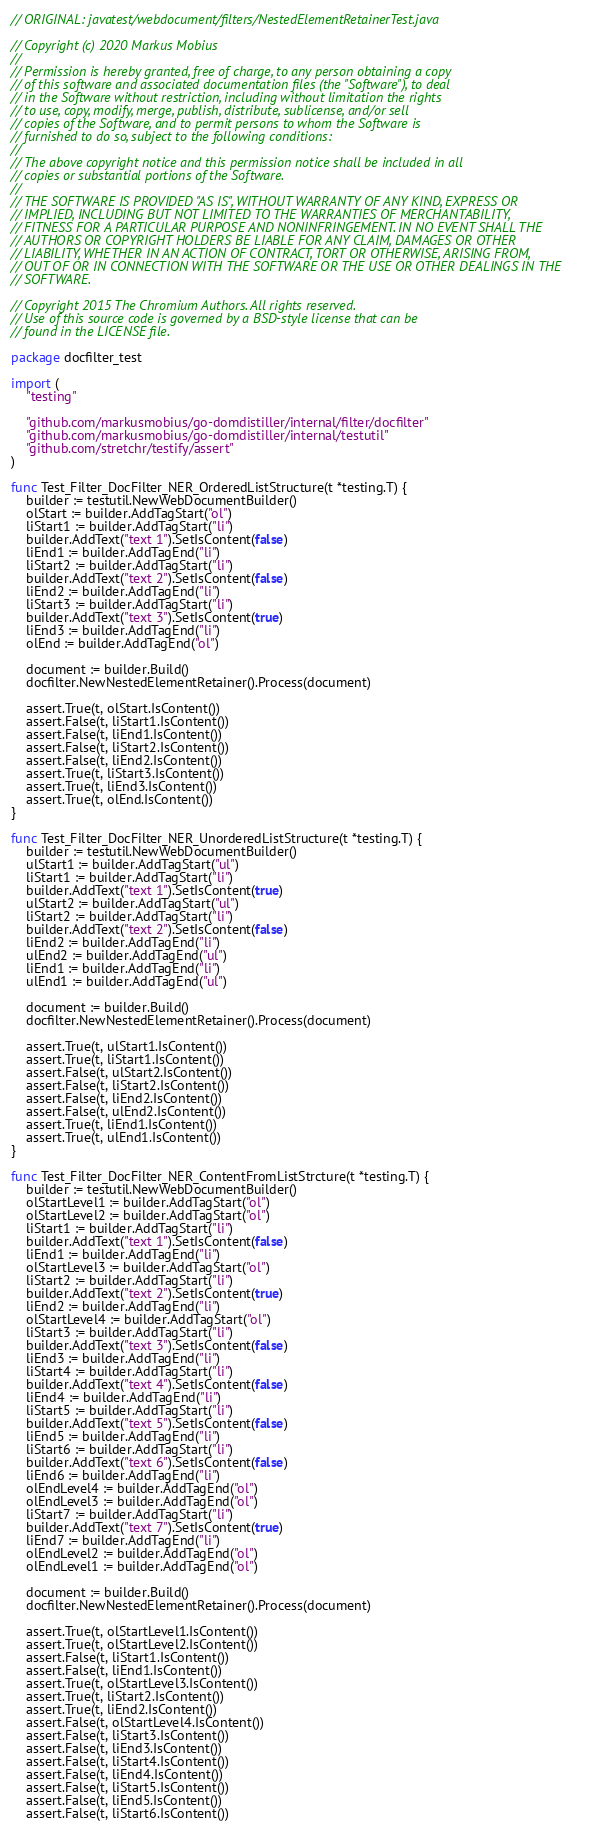Convert code to text. <code><loc_0><loc_0><loc_500><loc_500><_Go_>// ORIGINAL: javatest/webdocument/filters/NestedElementRetainerTest.java

// Copyright (c) 2020 Markus Mobius
//
// Permission is hereby granted, free of charge, to any person obtaining a copy
// of this software and associated documentation files (the "Software"), to deal
// in the Software without restriction, including without limitation the rights
// to use, copy, modify, merge, publish, distribute, sublicense, and/or sell
// copies of the Software, and to permit persons to whom the Software is
// furnished to do so, subject to the following conditions:
//
// The above copyright notice and this permission notice shall be included in all
// copies or substantial portions of the Software.
//
// THE SOFTWARE IS PROVIDED "AS IS", WITHOUT WARRANTY OF ANY KIND, EXPRESS OR
// IMPLIED, INCLUDING BUT NOT LIMITED TO THE WARRANTIES OF MERCHANTABILITY,
// FITNESS FOR A PARTICULAR PURPOSE AND NONINFRINGEMENT. IN NO EVENT SHALL THE
// AUTHORS OR COPYRIGHT HOLDERS BE LIABLE FOR ANY CLAIM, DAMAGES OR OTHER
// LIABILITY, WHETHER IN AN ACTION OF CONTRACT, TORT OR OTHERWISE, ARISING FROM,
// OUT OF OR IN CONNECTION WITH THE SOFTWARE OR THE USE OR OTHER DEALINGS IN THE
// SOFTWARE.

// Copyright 2015 The Chromium Authors. All rights reserved.
// Use of this source code is governed by a BSD-style license that can be
// found in the LICENSE file.

package docfilter_test

import (
	"testing"

	"github.com/markusmobius/go-domdistiller/internal/filter/docfilter"
	"github.com/markusmobius/go-domdistiller/internal/testutil"
	"github.com/stretchr/testify/assert"
)

func Test_Filter_DocFilter_NER_OrderedListStructure(t *testing.T) {
	builder := testutil.NewWebDocumentBuilder()
	olStart := builder.AddTagStart("ol")
	liStart1 := builder.AddTagStart("li")
	builder.AddText("text 1").SetIsContent(false)
	liEnd1 := builder.AddTagEnd("li")
	liStart2 := builder.AddTagStart("li")
	builder.AddText("text 2").SetIsContent(false)
	liEnd2 := builder.AddTagEnd("li")
	liStart3 := builder.AddTagStart("li")
	builder.AddText("text 3").SetIsContent(true)
	liEnd3 := builder.AddTagEnd("li")
	olEnd := builder.AddTagEnd("ol")

	document := builder.Build()
	docfilter.NewNestedElementRetainer().Process(document)

	assert.True(t, olStart.IsContent())
	assert.False(t, liStart1.IsContent())
	assert.False(t, liEnd1.IsContent())
	assert.False(t, liStart2.IsContent())
	assert.False(t, liEnd2.IsContent())
	assert.True(t, liStart3.IsContent())
	assert.True(t, liEnd3.IsContent())
	assert.True(t, olEnd.IsContent())
}

func Test_Filter_DocFilter_NER_UnorderedListStructure(t *testing.T) {
	builder := testutil.NewWebDocumentBuilder()
	ulStart1 := builder.AddTagStart("ul")
	liStart1 := builder.AddTagStart("li")
	builder.AddText("text 1").SetIsContent(true)
	ulStart2 := builder.AddTagStart("ul")
	liStart2 := builder.AddTagStart("li")
	builder.AddText("text 2").SetIsContent(false)
	liEnd2 := builder.AddTagEnd("li")
	ulEnd2 := builder.AddTagEnd("ul")
	liEnd1 := builder.AddTagEnd("li")
	ulEnd1 := builder.AddTagEnd("ul")

	document := builder.Build()
	docfilter.NewNestedElementRetainer().Process(document)

	assert.True(t, ulStart1.IsContent())
	assert.True(t, liStart1.IsContent())
	assert.False(t, ulStart2.IsContent())
	assert.False(t, liStart2.IsContent())
	assert.False(t, liEnd2.IsContent())
	assert.False(t, ulEnd2.IsContent())
	assert.True(t, liEnd1.IsContent())
	assert.True(t, ulEnd1.IsContent())
}

func Test_Filter_DocFilter_NER_ContentFromListStrcture(t *testing.T) {
	builder := testutil.NewWebDocumentBuilder()
	olStartLevel1 := builder.AddTagStart("ol")
	olStartLevel2 := builder.AddTagStart("ol")
	liStart1 := builder.AddTagStart("li")
	builder.AddText("text 1").SetIsContent(false)
	liEnd1 := builder.AddTagEnd("li")
	olStartLevel3 := builder.AddTagStart("ol")
	liStart2 := builder.AddTagStart("li")
	builder.AddText("text 2").SetIsContent(true)
	liEnd2 := builder.AddTagEnd("li")
	olStartLevel4 := builder.AddTagStart("ol")
	liStart3 := builder.AddTagStart("li")
	builder.AddText("text 3").SetIsContent(false)
	liEnd3 := builder.AddTagEnd("li")
	liStart4 := builder.AddTagStart("li")
	builder.AddText("text 4").SetIsContent(false)
	liEnd4 := builder.AddTagEnd("li")
	liStart5 := builder.AddTagStart("li")
	builder.AddText("text 5").SetIsContent(false)
	liEnd5 := builder.AddTagEnd("li")
	liStart6 := builder.AddTagStart("li")
	builder.AddText("text 6").SetIsContent(false)
	liEnd6 := builder.AddTagEnd("li")
	olEndLevel4 := builder.AddTagEnd("ol")
	olEndLevel3 := builder.AddTagEnd("ol")
	liStart7 := builder.AddTagStart("li")
	builder.AddText("text 7").SetIsContent(true)
	liEnd7 := builder.AddTagEnd("li")
	olEndLevel2 := builder.AddTagEnd("ol")
	olEndLevel1 := builder.AddTagEnd("ol")

	document := builder.Build()
	docfilter.NewNestedElementRetainer().Process(document)

	assert.True(t, olStartLevel1.IsContent())
	assert.True(t, olStartLevel2.IsContent())
	assert.False(t, liStart1.IsContent())
	assert.False(t, liEnd1.IsContent())
	assert.True(t, olStartLevel3.IsContent())
	assert.True(t, liStart2.IsContent())
	assert.True(t, liEnd2.IsContent())
	assert.False(t, olStartLevel4.IsContent())
	assert.False(t, liStart3.IsContent())
	assert.False(t, liEnd3.IsContent())
	assert.False(t, liStart4.IsContent())
	assert.False(t, liEnd4.IsContent())
	assert.False(t, liStart5.IsContent())
	assert.False(t, liEnd5.IsContent())
	assert.False(t, liStart6.IsContent())</code> 